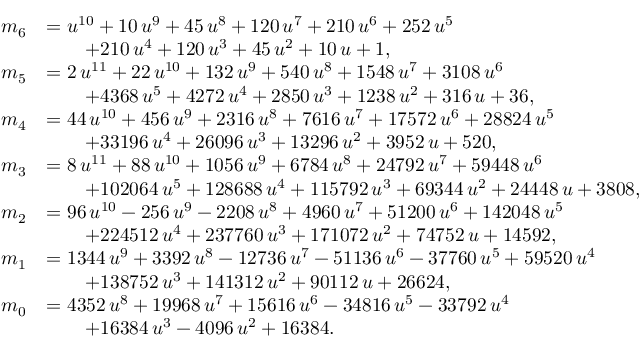Convert formula to latex. <formula><loc_0><loc_0><loc_500><loc_500>\begin{array} { r l } { m _ { 6 } } & { = { u } ^ { 1 0 } + 1 0 \, { u } ^ { 9 } + 4 5 \, { u } ^ { 8 } + 1 2 0 \, { u } ^ { 7 } + 2 1 0 \, { u } ^ { 6 } + 2 5 2 \, { u } ^ { 5 } } \\ & { \quad + 2 1 0 \, { u } ^ { 4 } + 1 2 0 \, { u } ^ { 3 } + 4 5 \, { u } ^ { 2 } + 1 0 \, u + 1 , } \\ { m _ { 5 } } & { = 2 \, { u } ^ { 1 1 } + 2 2 \, { u } ^ { 1 0 } + 1 3 2 \, { u } ^ { 9 } + 5 4 0 \, { u } ^ { 8 } + 1 5 4 8 \, { u } ^ { 7 } + 3 1 0 8 \, { u } ^ { 6 } } \\ & { \quad + 4 3 6 8 \, { u } ^ { 5 } + 4 2 7 2 \, { u } ^ { 4 } + 2 8 5 0 \, { u } ^ { 3 } + 1 2 3 8 \, { u } ^ { 2 } + 3 1 6 \, u + 3 6 , } \\ { m _ { 4 } } & { = 4 4 \, { u } ^ { 1 0 } + 4 5 6 \, { u } ^ { 9 } + 2 3 1 6 \, { u } ^ { 8 } + 7 6 1 6 \, { u } ^ { 7 } + 1 7 5 7 2 \, { u } ^ { 6 } + 2 8 8 2 4 \, { u } ^ { 5 } } \\ & { \quad + 3 3 1 9 6 \, { u } ^ { 4 } + 2 6 0 9 6 \, { u } ^ { 3 } + 1 3 2 9 6 \, { u } ^ { 2 } + 3 9 5 2 \, u + 5 2 0 , } \\ { m _ { 3 } } & { = 8 \, { u } ^ { 1 1 } + 8 8 \, { u } ^ { 1 0 } + 1 0 5 6 \, { u } ^ { 9 } + 6 7 8 4 \, { u } ^ { 8 } + 2 4 7 9 2 \, { u } ^ { 7 } + 5 9 4 4 8 \, { u } ^ { 6 } } \\ & { \quad + 1 0 2 0 6 4 \, { u } ^ { 5 } + 1 2 8 6 8 8 \, { u } ^ { 4 } + 1 1 5 7 9 2 \, { u } ^ { 3 } + 6 9 3 4 4 \, { u } ^ { 2 } + 2 4 4 4 8 \, u + 3 8 0 8 , } \\ { m _ { 2 } } & { = 9 6 \, { u } ^ { 1 0 } - 2 5 6 \, { u } ^ { 9 } - 2 2 0 8 \, { u } ^ { 8 } + 4 9 6 0 \, { u } ^ { 7 } + 5 1 2 0 0 \, { u } ^ { 6 } + 1 4 2 0 4 8 \, { u } ^ { 5 } } \\ & { \quad + 2 2 4 5 1 2 \, { u } ^ { 4 } + 2 3 7 7 6 0 \, { u } ^ { 3 } + 1 7 1 0 7 2 \, { u } ^ { 2 } + 7 4 7 5 2 \, u + 1 4 5 9 2 , } \\ { m _ { 1 } } & { = 1 3 4 4 \, { u } ^ { 9 } + 3 3 9 2 \, { u } ^ { 8 } - 1 2 7 3 6 \, { u } ^ { 7 } - 5 1 1 3 6 \, { u } ^ { 6 } - 3 7 7 6 0 \, { u } ^ { 5 } + 5 9 5 2 0 \, { u } ^ { 4 } } \\ & { \quad + 1 3 8 7 5 2 \, { u } ^ { 3 } + 1 4 1 3 1 2 \, { u } ^ { 2 } + 9 0 1 1 2 \, u + 2 6 6 2 4 , } \\ { m _ { 0 } } & { = 4 3 5 2 \, { u } ^ { 8 } + 1 9 9 6 8 \, { u } ^ { 7 } + 1 5 6 1 6 \, { u } ^ { 6 } - 3 4 8 1 6 \, { u } ^ { 5 } - 3 3 7 9 2 \, { u } ^ { 4 } } \\ & { \quad + 1 6 3 8 4 \, { u } ^ { 3 } - 4 0 9 6 \, { u } ^ { 2 } + 1 6 3 8 4 . } \end{array}</formula> 